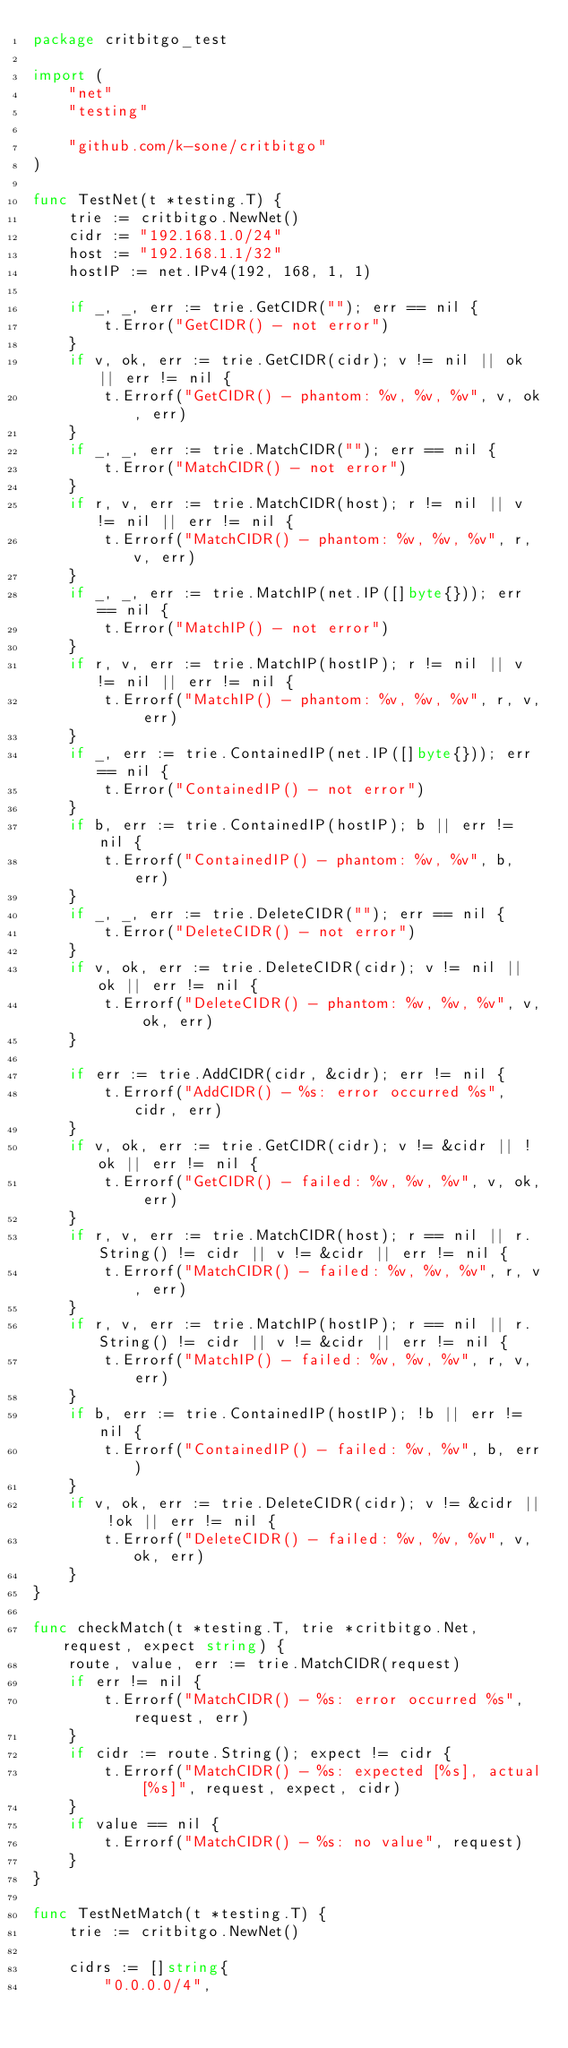<code> <loc_0><loc_0><loc_500><loc_500><_Go_>package critbitgo_test

import (
	"net"
	"testing"

	"github.com/k-sone/critbitgo"
)

func TestNet(t *testing.T) {
	trie := critbitgo.NewNet()
	cidr := "192.168.1.0/24"
	host := "192.168.1.1/32"
	hostIP := net.IPv4(192, 168, 1, 1)

	if _, _, err := trie.GetCIDR(""); err == nil {
		t.Error("GetCIDR() - not error")
	}
	if v, ok, err := trie.GetCIDR(cidr); v != nil || ok || err != nil {
		t.Errorf("GetCIDR() - phantom: %v, %v, %v", v, ok, err)
	}
	if _, _, err := trie.MatchCIDR(""); err == nil {
		t.Error("MatchCIDR() - not error")
	}
	if r, v, err := trie.MatchCIDR(host); r != nil || v != nil || err != nil {
		t.Errorf("MatchCIDR() - phantom: %v, %v, %v", r, v, err)
	}
	if _, _, err := trie.MatchIP(net.IP([]byte{})); err == nil {
		t.Error("MatchIP() - not error")
	}
	if r, v, err := trie.MatchIP(hostIP); r != nil || v != nil || err != nil {
		t.Errorf("MatchIP() - phantom: %v, %v, %v", r, v, err)
	}
	if _, err := trie.ContainedIP(net.IP([]byte{})); err == nil {
		t.Error("ContainedIP() - not error")
	}
	if b, err := trie.ContainedIP(hostIP); b || err != nil {
		t.Errorf("ContainedIP() - phantom: %v, %v", b, err)
	}
	if _, _, err := trie.DeleteCIDR(""); err == nil {
		t.Error("DeleteCIDR() - not error")
	}
	if v, ok, err := trie.DeleteCIDR(cidr); v != nil || ok || err != nil {
		t.Errorf("DeleteCIDR() - phantom: %v, %v, %v", v, ok, err)
	}

	if err := trie.AddCIDR(cidr, &cidr); err != nil {
		t.Errorf("AddCIDR() - %s: error occurred %s", cidr, err)
	}
	if v, ok, err := trie.GetCIDR(cidr); v != &cidr || !ok || err != nil {
		t.Errorf("GetCIDR() - failed: %v, %v, %v", v, ok, err)
	}
	if r, v, err := trie.MatchCIDR(host); r == nil || r.String() != cidr || v != &cidr || err != nil {
		t.Errorf("MatchCIDR() - failed: %v, %v, %v", r, v, err)
	}
	if r, v, err := trie.MatchIP(hostIP); r == nil || r.String() != cidr || v != &cidr || err != nil {
		t.Errorf("MatchIP() - failed: %v, %v, %v", r, v, err)
	}
	if b, err := trie.ContainedIP(hostIP); !b || err != nil {
		t.Errorf("ContainedIP() - failed: %v, %v", b, err)
	}
	if v, ok, err := trie.DeleteCIDR(cidr); v != &cidr || !ok || err != nil {
		t.Errorf("DeleteCIDR() - failed: %v, %v, %v", v, ok, err)
	}
}

func checkMatch(t *testing.T, trie *critbitgo.Net, request, expect string) {
	route, value, err := trie.MatchCIDR(request)
	if err != nil {
		t.Errorf("MatchCIDR() - %s: error occurred %s", request, err)
	}
	if cidr := route.String(); expect != cidr {
		t.Errorf("MatchCIDR() - %s: expected [%s], actual [%s]", request, expect, cidr)
	}
	if value == nil {
		t.Errorf("MatchCIDR() - %s: no value", request)
	}
}

func TestNetMatch(t *testing.T) {
	trie := critbitgo.NewNet()

	cidrs := []string{
		"0.0.0.0/4",</code> 